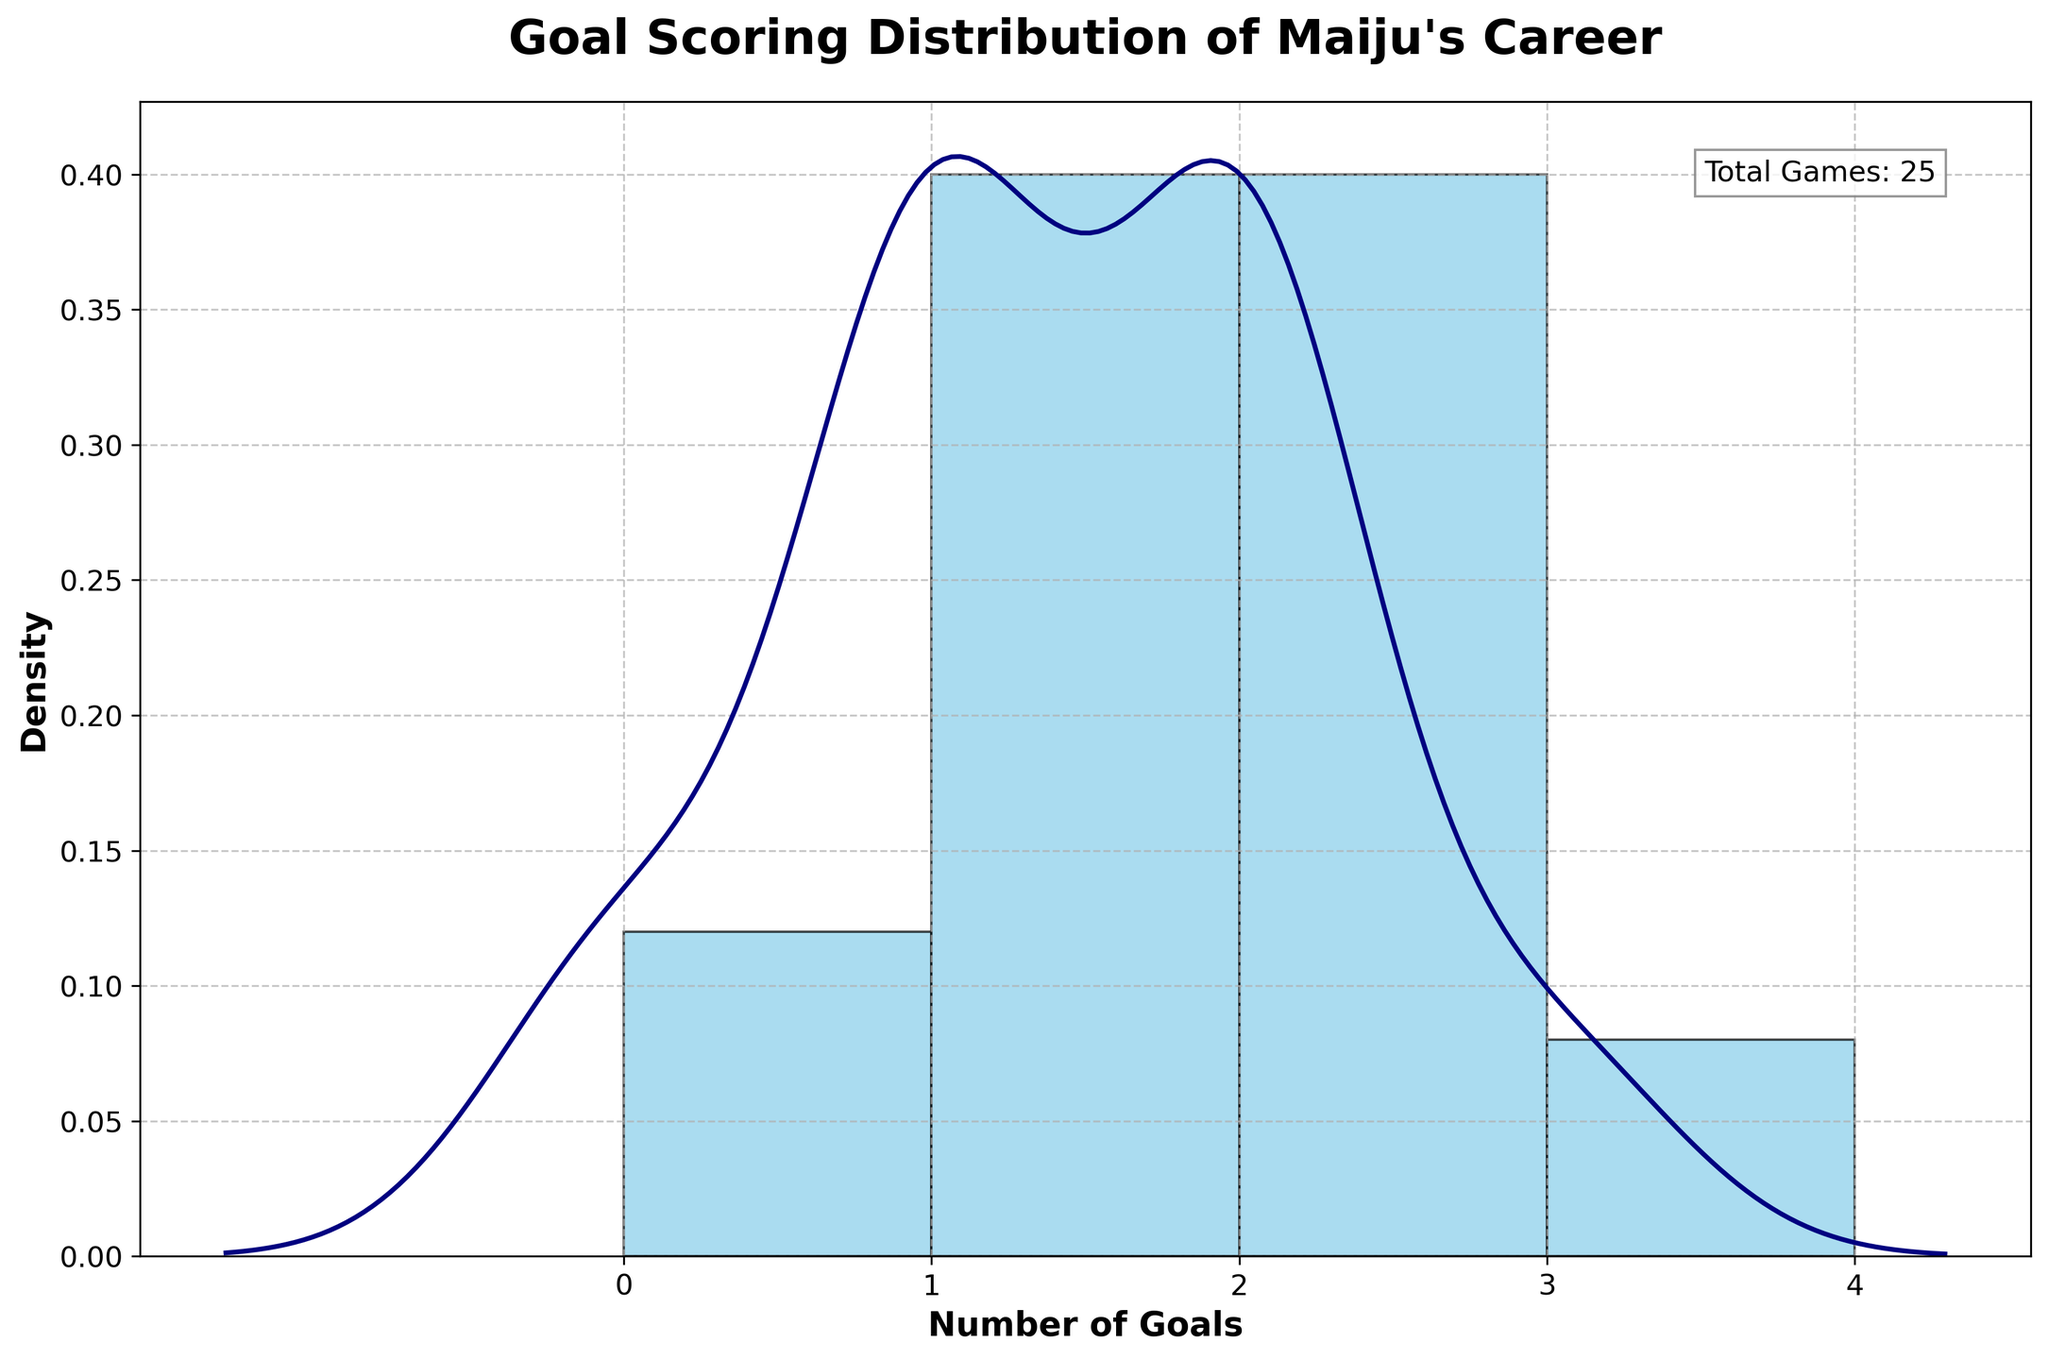what is the title of the plot? The title of the plot is generally located at the top of the figure and is used to describe the overall content of the plot. By reading the text at the top, we can determine the title.
Answer: "Goal Scoring Distribution of Maiju's Career" what is the x-axis label of the plot? The x-axis label helps us understand what the horizontal axis represents. By looking at the text directly beneath the x-axis, we can identify the label.
Answer: "Number of Goals" how many total games did Maiju play according to the plot? The total number of games is typically annotated in the top corner of the plot. By identifying this annotation, we can determine the total games played.
Answer: "Total Games: 25" what is the most common number of goals scored in a game? To find the most common number of goals, we look at the peak of the histogram's bars, the highest bar represents the most typical number of goals scored in a game.
Answer: 1 goal how do the number of times Maiju scored 0 goals compare to the number of times she scored 3 goals? By comparing the height of the bars corresponding to 0 and 3 on the x-axis, we can determine which bar is taller, indicating more frequent occurrences.
Answer: Scored 0 goals more often which number of goals appears to have the lowest frequency? The least frequent number of goals can be identified by looking at the shortest bar in the histogram, which indicates the minimal occurrences.
Answer: 3 goals how many different scoring values are represented in the plot? The distinct scoring values can be counted by noting the horizontal tick marks along the x-axis, which represent the unique scoring outcomes.
Answer: 4 scoring values does Maiju's distribution of goals lean more towards scoring fewer or more goals per game? By examining the shape of the density plot and the histogram, if the plot is skewed more to the left or peak around lower values, it indicates scoring fewer goals.
Answer: More towards scoring fewer goals which range contains the most goal occurrences? To determine which range contains the highest number of goals, identify the range of the histogram bar with the greatest height along the x-axis.
Answer: 1 goal range is there a significant difference between the frequency of scoring 2 goals and other goals? By comparing the height of the bar corresponding to scoring 2 goals with the heights of the other bars, we can assess whether the difference is substantial.
Answer: No significant difference 